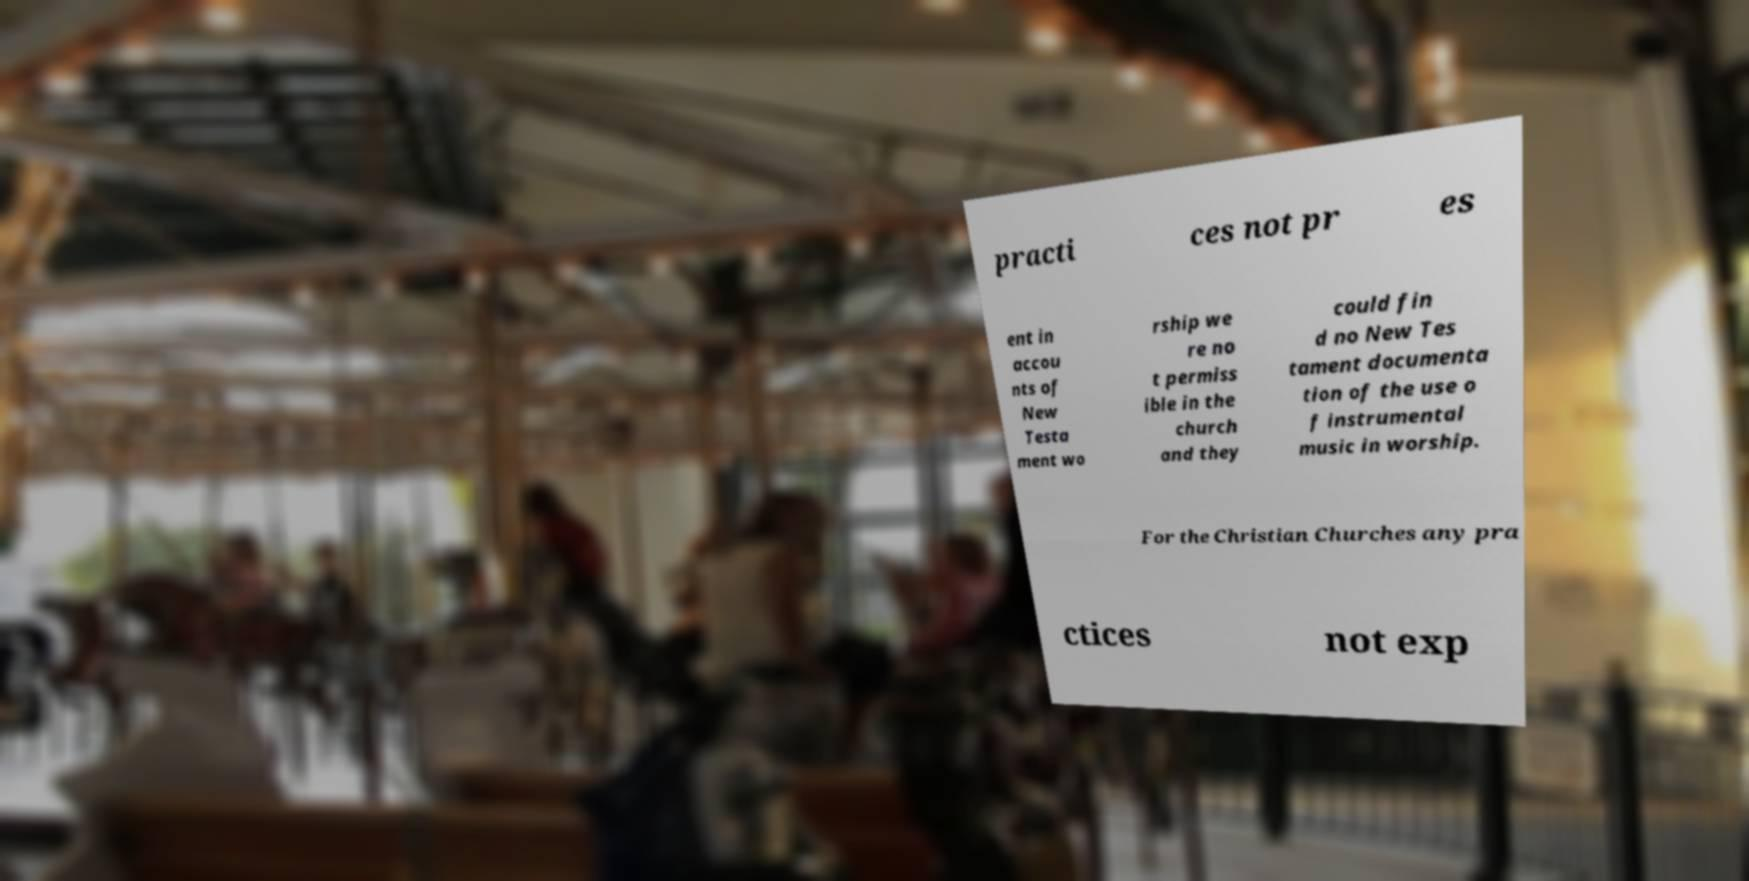What messages or text are displayed in this image? I need them in a readable, typed format. practi ces not pr es ent in accou nts of New Testa ment wo rship we re no t permiss ible in the church and they could fin d no New Tes tament documenta tion of the use o f instrumental music in worship. For the Christian Churches any pra ctices not exp 